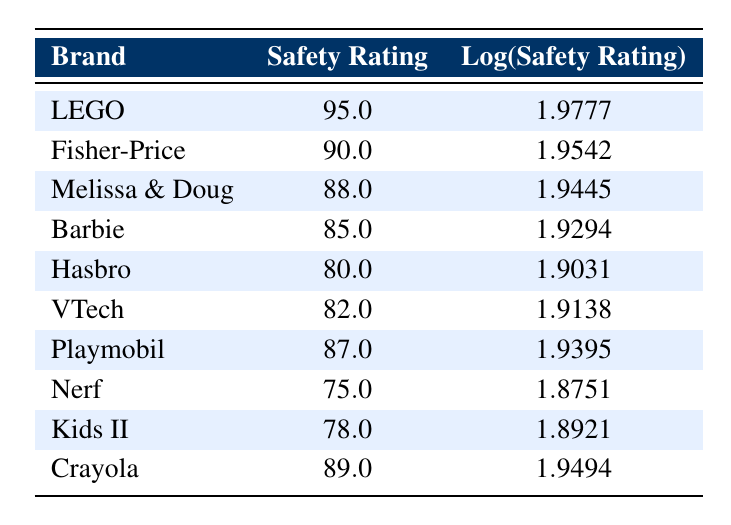What is the safety rating for LEGO? The table directly shows LEGO with a safety rating of 95.0.
Answer: 95.0 Which brand has the highest safety rating? LEGO has the highest safety rating listed, which is 95.0.
Answer: LEGO Is Barbie's safety rating greater than Hasbro's? Barbie has a safety rating of 85.0, while Hasbro has a safety rating of 80.0, so Barbie's rating is indeed greater.
Answer: Yes What is the difference in safety ratings between Melissa & Doug and VTech? Melissa & Doug has a safety rating of 88.0, and VTech has 82.0. The difference is 88.0 - 82.0 = 6.0.
Answer: 6.0 What is the average safety rating of the brands listed? The safety ratings are 95, 90, 88, 85, 80, 82, 87, 75, 78, and 89. Adding these together gives  95 + 90 + 88 + 85 + 80 + 82 + 87 + 75 + 78 + 89 =  89.5, and dividing by 10 (the number of brands) gives an average of 89.5.
Answer: 89.5 How many brands have a safety rating above 85? The brands with safety ratings above 85 are LEGO, Fisher-Price, Melissa & Doug, Crayola, and Playmobil, totaling 5 brands.
Answer: 5 Is the safety rating for Nerf higher than that of Kids II? Nerf has a safety rating of 75.0, while Kids II has a rating of 78.0, making Nerf's rating lower.
Answer: No Which brand has a safety rating closest to 80? Hasbro has a safety rating of 80.0, which is exactly 80, the closest value.
Answer: Hasbro What is the sum of the safety ratings for Fisher-Price and Crayola? Fisher-Price has a safety rating of 90.0 and Crayola has a rating of 89.0. Adding these together gives 90.0 + 89.0 = 179.0.
Answer: 179.0 